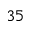<formula> <loc_0><loc_0><loc_500><loc_500>3 5</formula> 